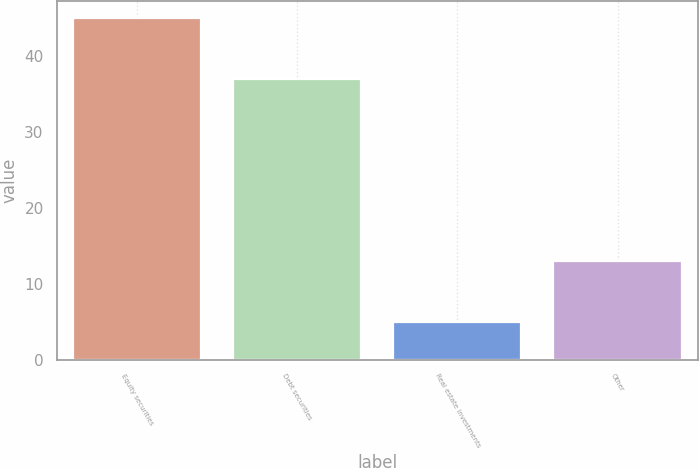Convert chart to OTSL. <chart><loc_0><loc_0><loc_500><loc_500><bar_chart><fcel>Equity securities<fcel>Debt securities<fcel>Real estate investments<fcel>Other<nl><fcel>45<fcel>37<fcel>5<fcel>13<nl></chart> 